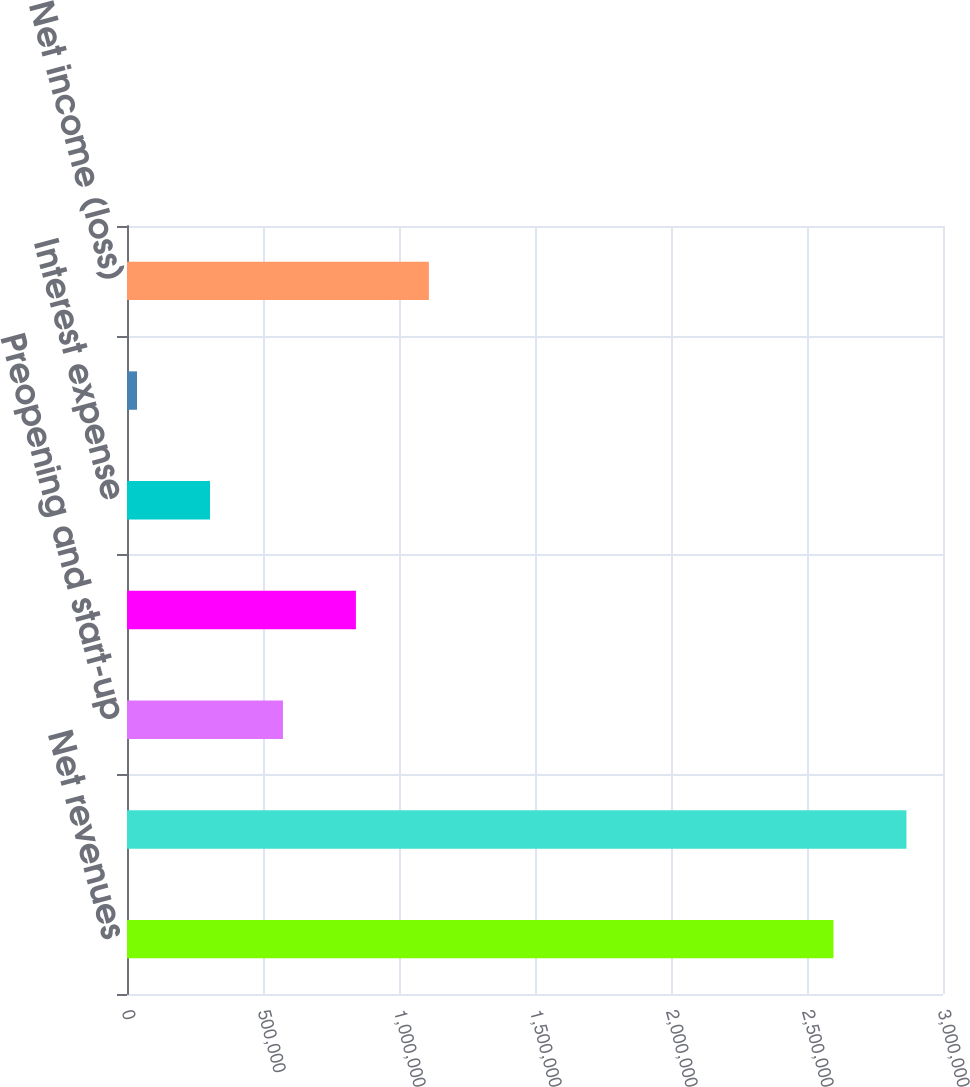Convert chart. <chart><loc_0><loc_0><loc_500><loc_500><bar_chart><fcel>Net revenues<fcel>Operating expenses except<fcel>Preopening and start-up<fcel>Operating income (loss)<fcel>Interest expense<fcel>Other non-operating income<fcel>Net income (loss)<nl><fcel>2.59737e+06<fcel>2.86562e+06<fcel>573363<fcel>841614<fcel>305112<fcel>36861<fcel>1.10986e+06<nl></chart> 